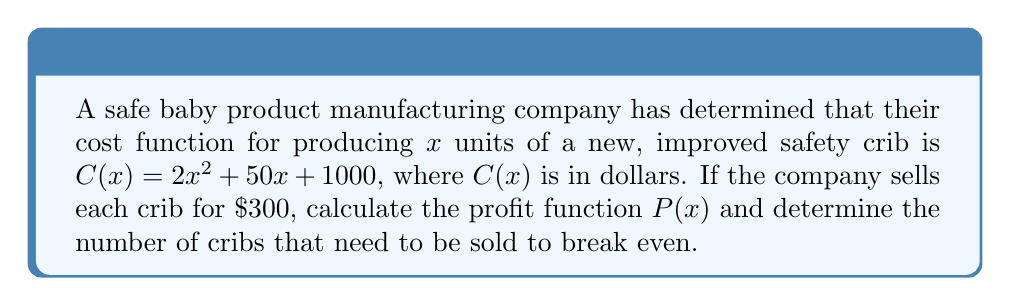What is the answer to this math problem? To solve this problem, we'll follow these steps:

1. Define the revenue function R(x):
   The company sells each crib for $300, so the revenue function is:
   $R(x) = 300x$

2. Recall the profit function formula:
   Profit = Revenue - Cost
   $P(x) = R(x) - C(x)$

3. Substitute the known functions:
   $P(x) = 300x - (2x^2 + 50x + 1000)$

4. Simplify the profit function:
   $P(x) = 300x - 2x^2 - 50x - 1000$
   $P(x) = -2x^2 + 250x - 1000$

5. To find the break-even point, set P(x) = 0:
   $0 = -2x^2 + 250x - 1000$

6. Solve the quadratic equation:
   $2x^2 - 250x + 1000 = 0$
   
   Using the quadratic formula: $x = \frac{-b \pm \sqrt{b^2 - 4ac}}{2a}$
   
   Where $a = 2$, $b = -250$, and $c = 1000$
   
   $x = \frac{250 \pm \sqrt{250^2 - 4(2)(1000)}}{2(2)}$
   
   $x = \frac{250 \pm \sqrt{62500 - 8000}}{4}$
   
   $x = \frac{250 \pm \sqrt{54500}}{4}$
   
   $x = \frac{250 \pm 233.45}{4}$

7. This gives us two solutions:
   $x_1 = \frac{250 + 233.45}{4} \approx 120.86$
   $x_2 = \frac{250 - 233.45}{4} \approx 4.14$

   Since we can't sell a fraction of a crib, we round up to the nearest whole number for the break-even point: 121 cribs.
Answer: $P(x) = -2x^2 + 250x - 1000$; Break-even point: 121 cribs 